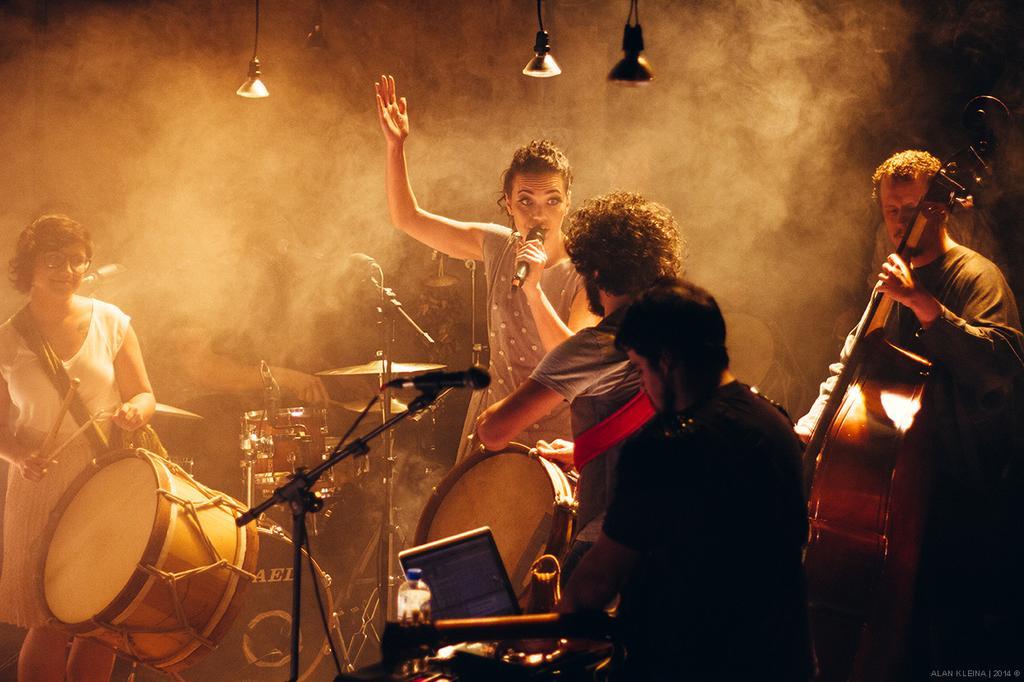Please provide a concise description of this image. Here a woman is singing on a microphone. on the left side of an image there is a woman with drums in his hands and the right side of an image there is a man who is playing guitar In the middle of an image there is a person looking into the laptop. 